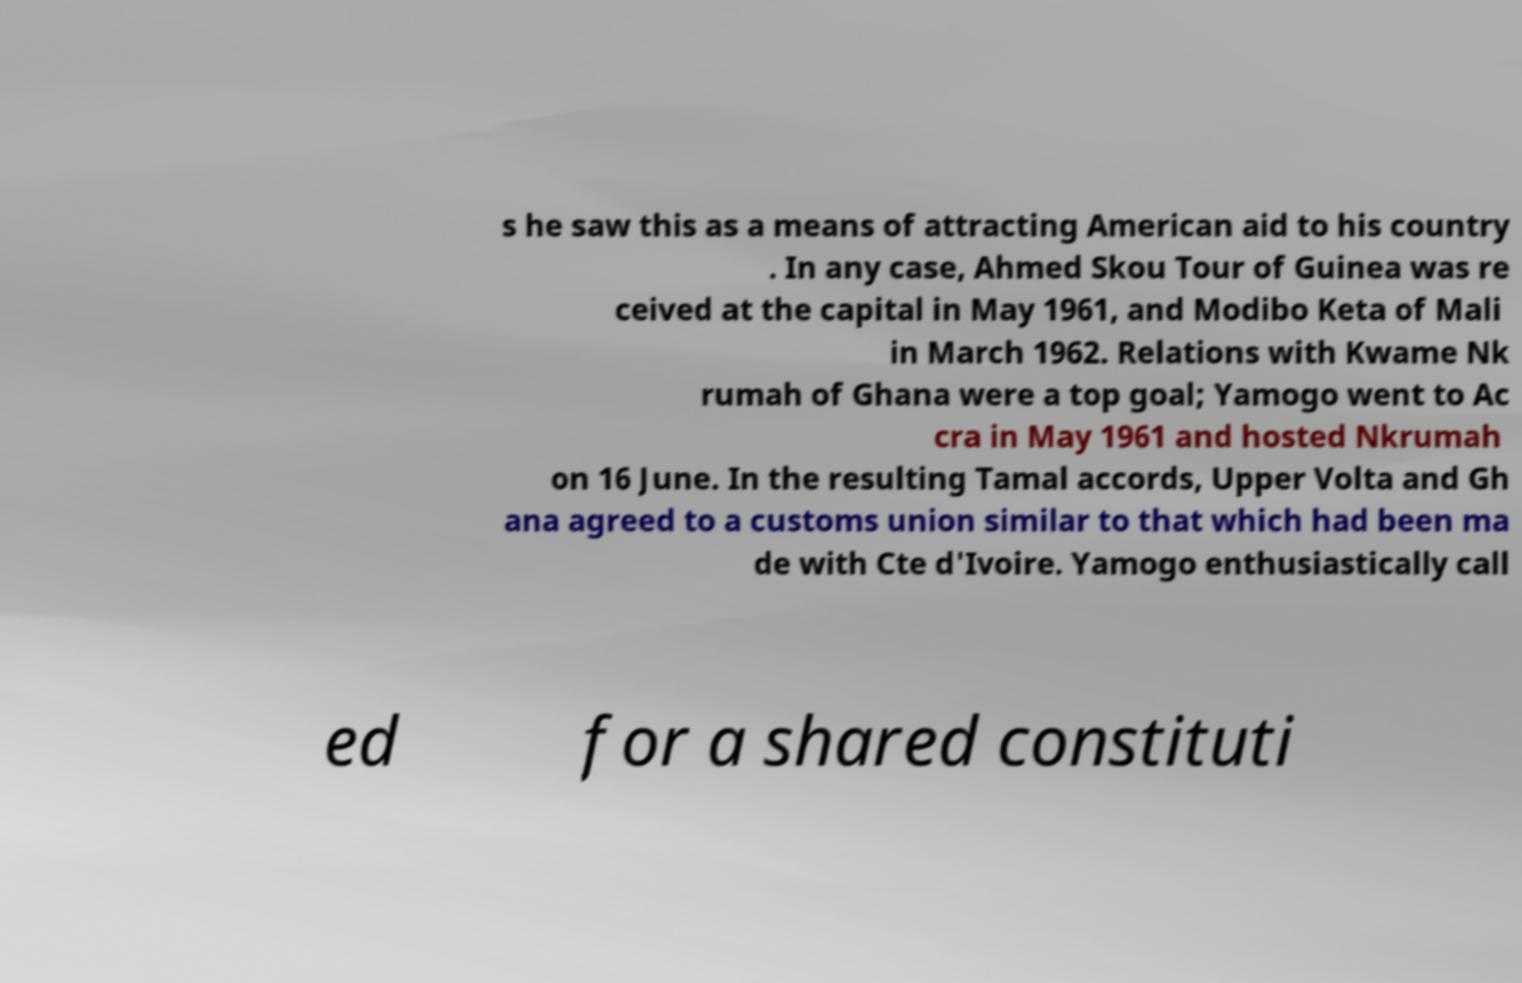For documentation purposes, I need the text within this image transcribed. Could you provide that? s he saw this as a means of attracting American aid to his country . In any case, Ahmed Skou Tour of Guinea was re ceived at the capital in May 1961, and Modibo Keta of Mali in March 1962. Relations with Kwame Nk rumah of Ghana were a top goal; Yamogo went to Ac cra in May 1961 and hosted Nkrumah on 16 June. In the resulting Tamal accords, Upper Volta and Gh ana agreed to a customs union similar to that which had been ma de with Cte d'Ivoire. Yamogo enthusiastically call ed for a shared constituti 